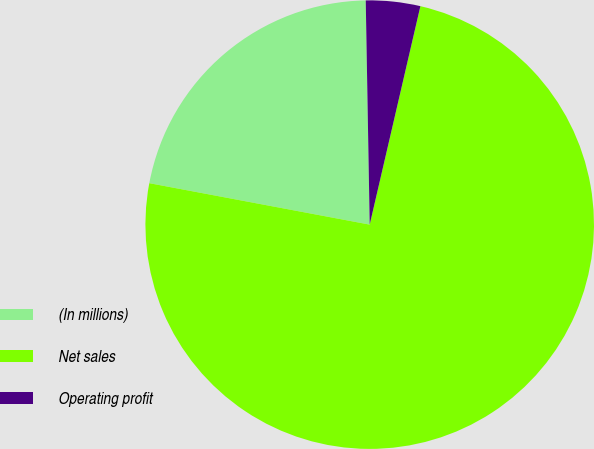Convert chart. <chart><loc_0><loc_0><loc_500><loc_500><pie_chart><fcel>(In millions)<fcel>Net sales<fcel>Operating profit<nl><fcel>21.76%<fcel>74.33%<fcel>3.91%<nl></chart> 